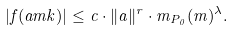<formula> <loc_0><loc_0><loc_500><loc_500>| f ( a m k ) | \leq c \cdot \| a \| ^ { r } \cdot m _ { P _ { 0 } } ( m ) ^ { \lambda } .</formula> 